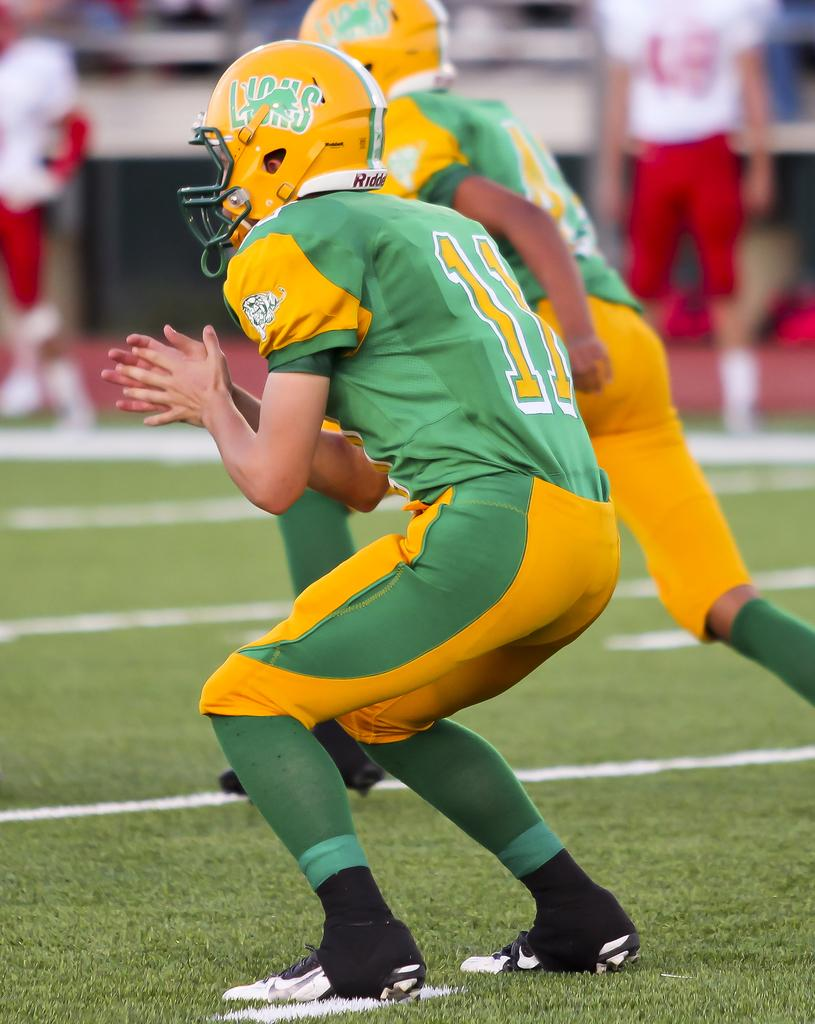How many people are present in the image? There are two persons in the image. What are the persons wearing on their heads? The persons are wearing helmets. What type of terrain is visible in the image? There is grass on the ground in the image. Can you describe the background of the image? The background of the image is blurred, and there are a few people visible in the background. What is the limit of the attack that the persons are preparing for in the image? There is no indication of an attack or any preparation for one in the image. 